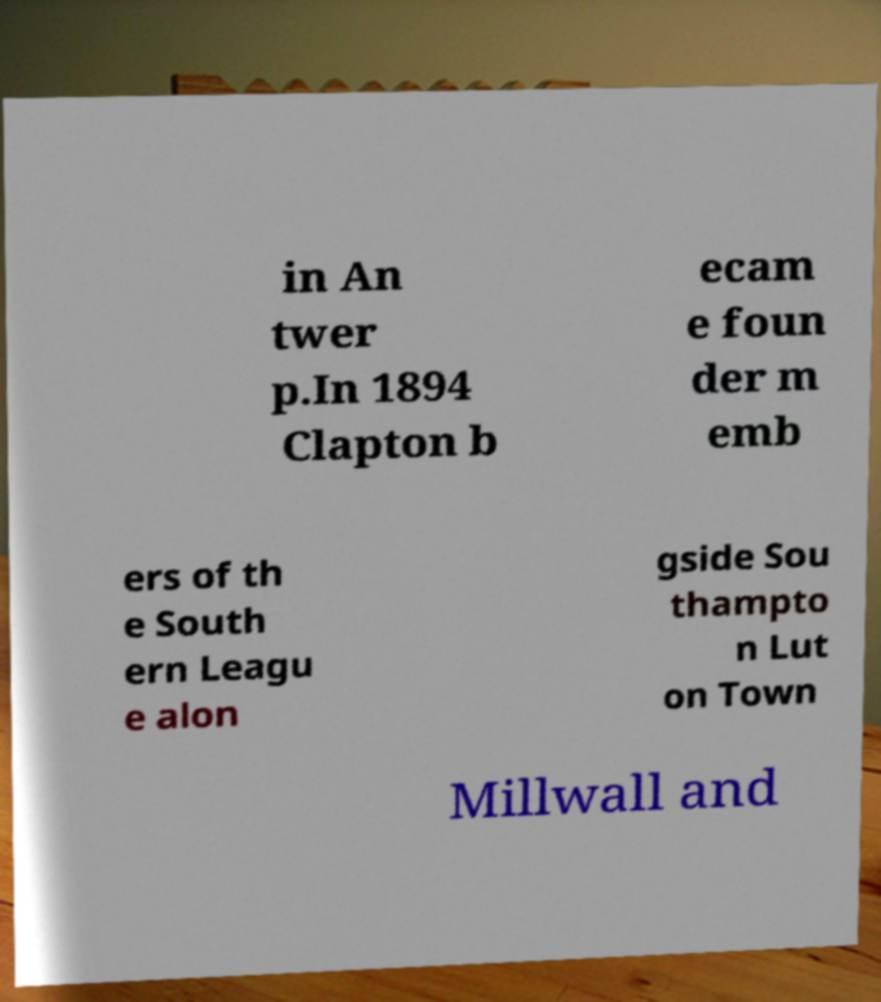Could you assist in decoding the text presented in this image and type it out clearly? in An twer p.In 1894 Clapton b ecam e foun der m emb ers of th e South ern Leagu e alon gside Sou thampto n Lut on Town Millwall and 